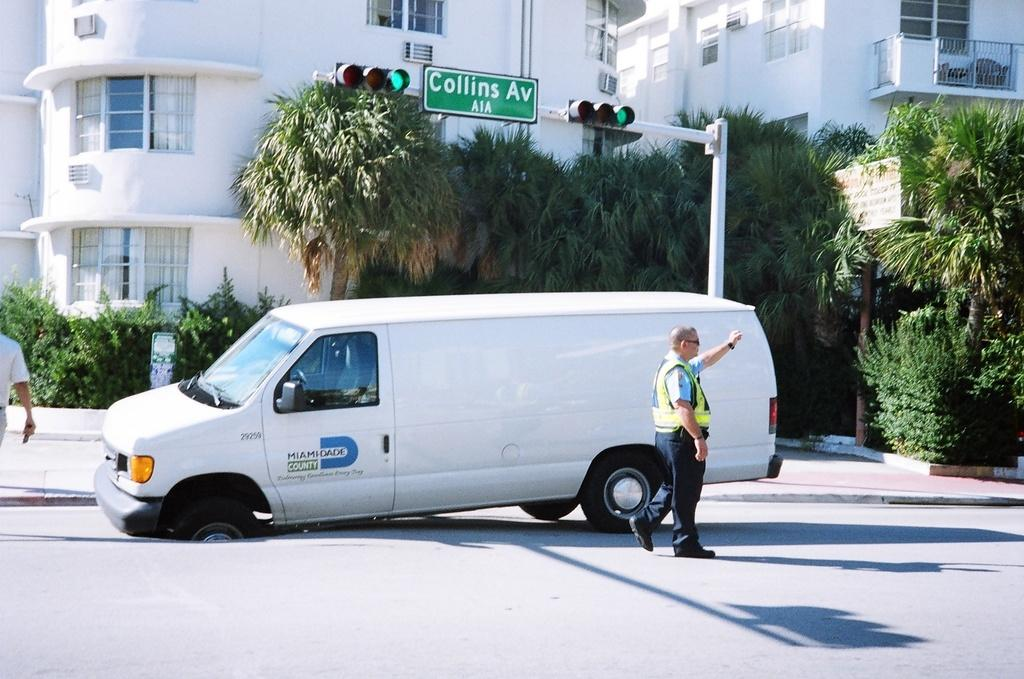<image>
Create a compact narrative representing the image presented. A van from Miami-Dade County has its tire stuck in a pothole. 